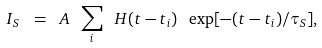Convert formula to latex. <formula><loc_0><loc_0><loc_500><loc_500>I _ { S } \ = \ A \ \sum _ { i } \ H ( t - t _ { i } ) \ \exp [ - ( t - t _ { i } ) / \tau _ { S } ] ,</formula> 